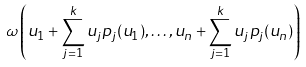Convert formula to latex. <formula><loc_0><loc_0><loc_500><loc_500>\omega \left ( u _ { 1 } + \sum _ { j = 1 } ^ { k } u _ { j } p _ { j } ( u _ { 1 } ) , \dots , u _ { n } + \sum _ { j = 1 } ^ { k } u _ { j } p _ { j } ( u _ { n } ) \right )</formula> 